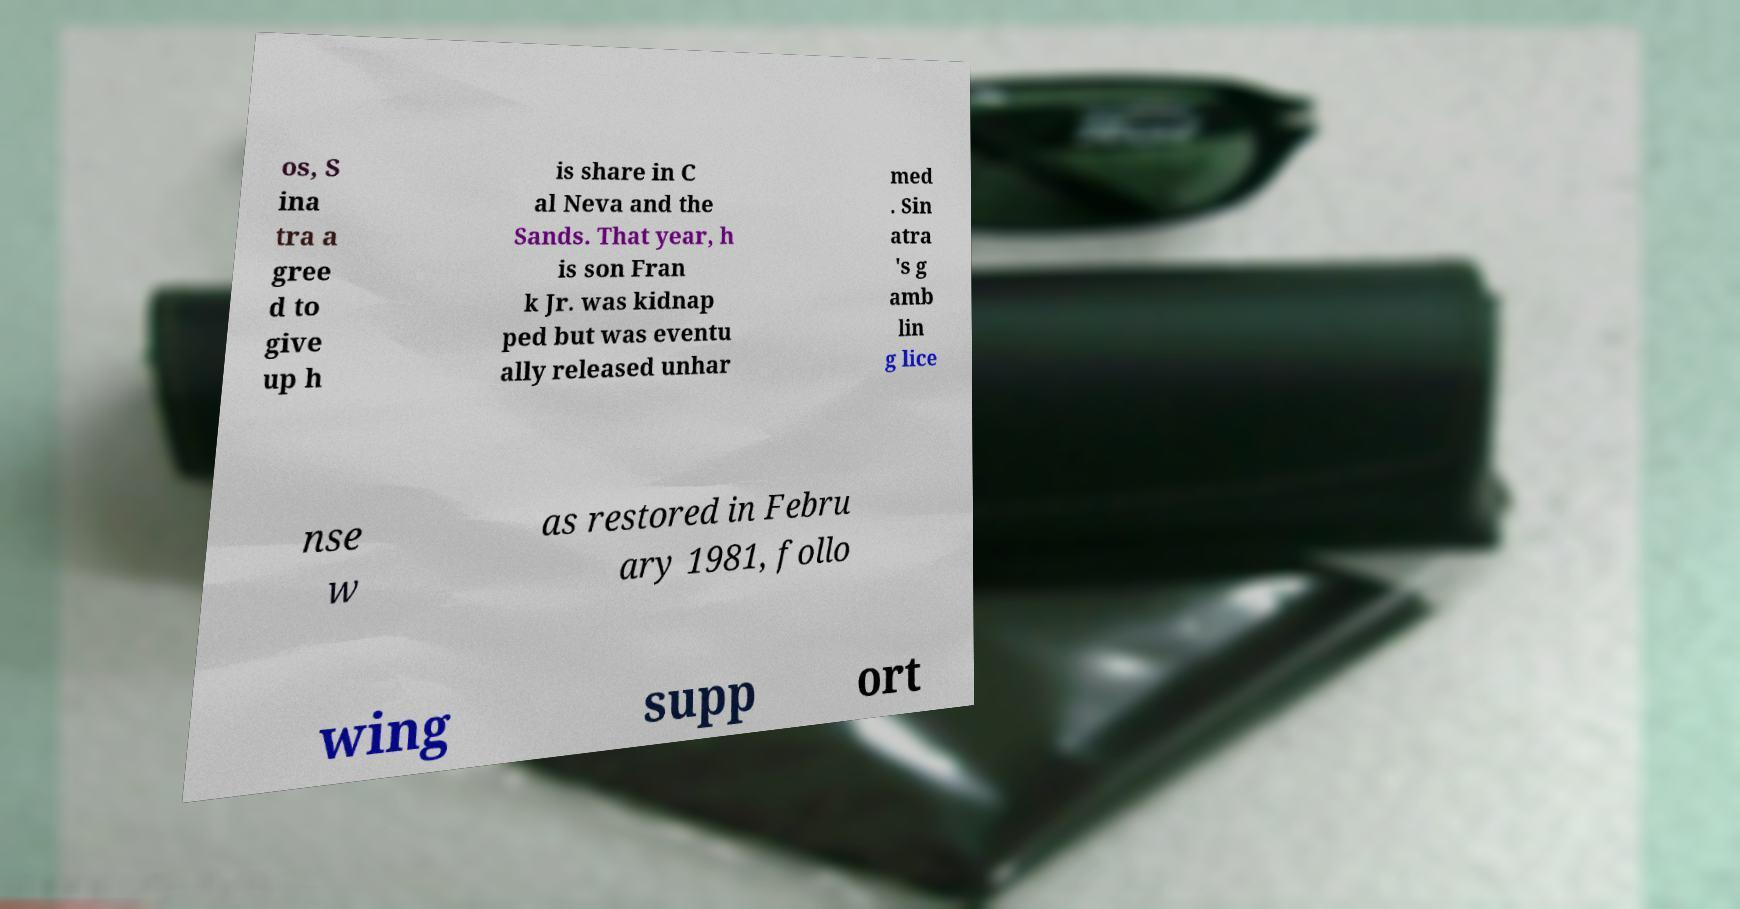For documentation purposes, I need the text within this image transcribed. Could you provide that? os, S ina tra a gree d to give up h is share in C al Neva and the Sands. That year, h is son Fran k Jr. was kidnap ped but was eventu ally released unhar med . Sin atra 's g amb lin g lice nse w as restored in Febru ary 1981, follo wing supp ort 